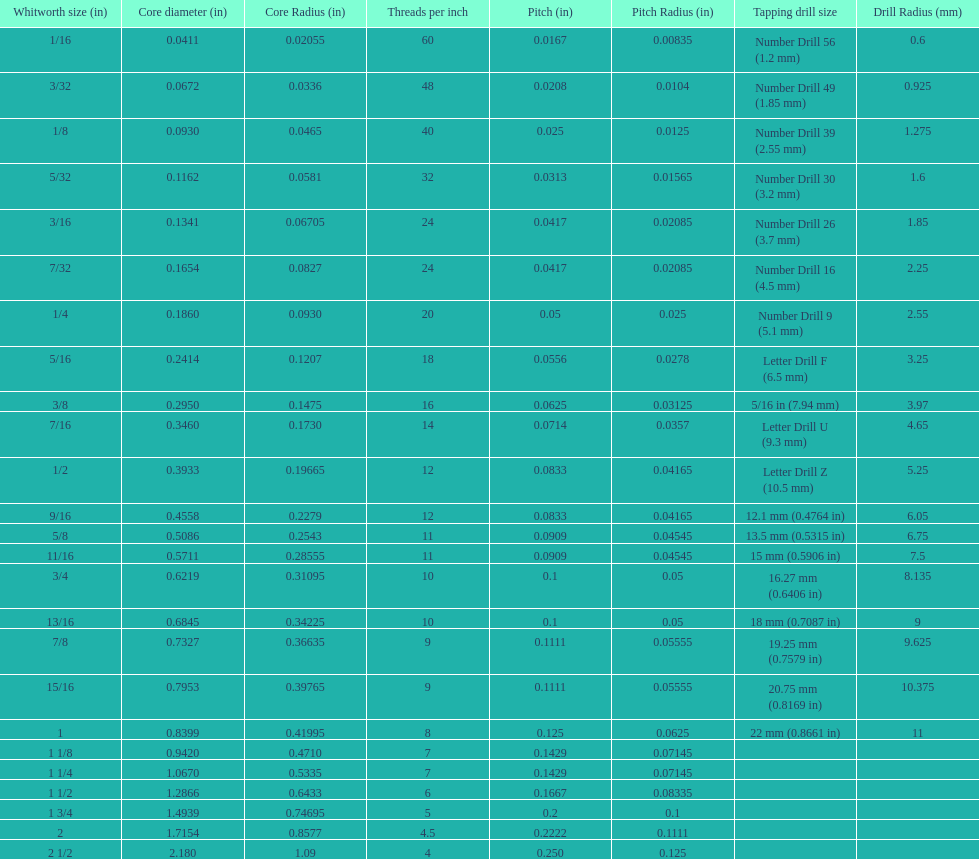What is the core diameter of the last whitworth thread size? 2.180. Would you mind parsing the complete table? {'header': ['Whitworth size (in)', 'Core diameter (in)', 'Core Radius (in)', 'Threads per\xa0inch', 'Pitch (in)', 'Pitch Radius (in)', 'Tapping drill size', 'Drill Radius (mm)'], 'rows': [['1/16', '0.0411', '0.02055', '60', '0.0167', '0.00835', 'Number Drill 56 (1.2\xa0mm)', '0.6'], ['3/32', '0.0672', '0.0336', '48', '0.0208', '0.0104', 'Number Drill 49 (1.85\xa0mm)', '0.925'], ['1/8', '0.0930', '0.0465', '40', '0.025', '0.0125', 'Number Drill 39 (2.55\xa0mm)', '1.275'], ['5/32', '0.1162', '0.0581', '32', '0.0313', '0.01565', 'Number Drill 30 (3.2\xa0mm)', '1.6'], ['3/16', '0.1341', '0.06705', '24', '0.0417', '0.02085', 'Number Drill 26 (3.7\xa0mm)', '1.85'], ['7/32', '0.1654', '0.0827', '24', '0.0417', '0.02085', 'Number Drill 16 (4.5\xa0mm)', '2.25'], ['1/4', '0.1860', '0.0930', '20', '0.05', '0.025', 'Number Drill 9 (5.1\xa0mm)', '2.55'], ['5/16', '0.2414', '0.1207', '18', '0.0556', '0.0278', 'Letter Drill F (6.5\xa0mm)', '3.25'], ['3/8', '0.2950', '0.1475', '16', '0.0625', '0.03125', '5/16\xa0in (7.94\xa0mm)', '3.97'], ['7/16', '0.3460', '0.1730', '14', '0.0714', '0.0357', 'Letter Drill U (9.3\xa0mm)', '4.65'], ['1/2', '0.3933', '0.19665', '12', '0.0833', '0.04165', 'Letter Drill Z (10.5\xa0mm)', '5.25'], ['9/16', '0.4558', '0.2279', '12', '0.0833', '0.04165', '12.1\xa0mm (0.4764\xa0in)', '6.05'], ['5/8', '0.5086', '0.2543', '11', '0.0909', '0.04545', '13.5\xa0mm (0.5315\xa0in)', '6.75'], ['11/16', '0.5711', '0.28555', '11', '0.0909', '0.04545', '15\xa0mm (0.5906\xa0in)', '7.5'], ['3/4', '0.6219', '0.31095', '10', '0.1', '0.05', '16.27\xa0mm (0.6406\xa0in)', '8.135'], ['13/16', '0.6845', '0.34225', '10', '0.1', '0.05', '18\xa0mm (0.7087\xa0in)', '9'], ['7/8', '0.7327', '0.36635', '9', '0.1111', '0.05555', '19.25\xa0mm (0.7579\xa0in)', '9.625'], ['15/16', '0.7953', '0.39765', '9', '0.1111', '0.05555', '20.75\xa0mm (0.8169\xa0in)', '10.375'], ['1', '0.8399', '0.41995', '8', '0.125', '0.0625', '22\xa0mm (0.8661\xa0in)', '11'], ['1 1/8', '0.9420', '0.4710', '7', '0.1429', '0.07145', '', ''], ['1 1/4', '1.0670', '0.5335', '7', '0.1429', '0.07145', '', ''], ['1 1/2', '1.2866', '0.6433', '6', '0.1667', '0.08335', '', ''], ['1 3/4', '1.4939', '0.74695', '5', '0.2', '0.1', '', ''], ['2', '1.7154', '0.8577', '4.5', '0.2222', '0.1111', '', ''], ['2 1/2', '2.180', '1.09', '4', '0.250', '0.125', '', '']]} 